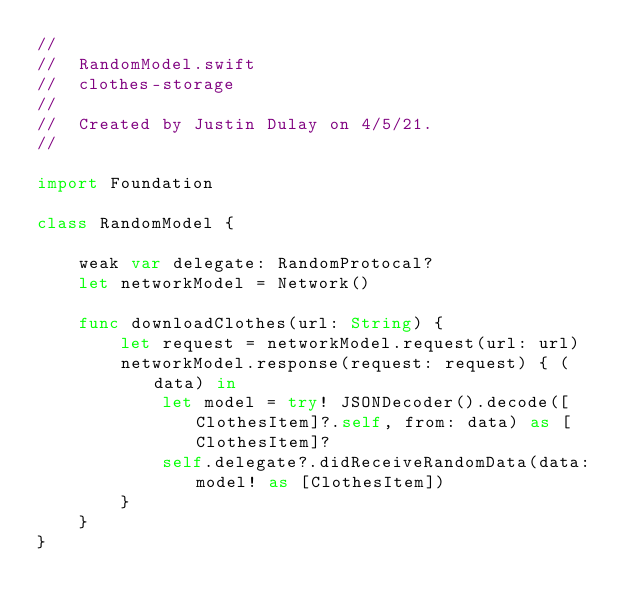<code> <loc_0><loc_0><loc_500><loc_500><_Swift_>//
//  RandomModel.swift
//  clothes-storage
//
//  Created by Justin Dulay on 4/5/21.
//

import Foundation

class RandomModel {
    
    weak var delegate: RandomProtocal?
    let networkModel = Network()
    
    func downloadClothes(url: String) {
        let request = networkModel.request(url: url)
        networkModel.response(request: request) { (data) in
            let model = try! JSONDecoder().decode([ClothesItem]?.self, from: data) as [ClothesItem]?
            self.delegate?.didReceiveRandomData(data: model! as [ClothesItem])
        }
    }
}
</code> 